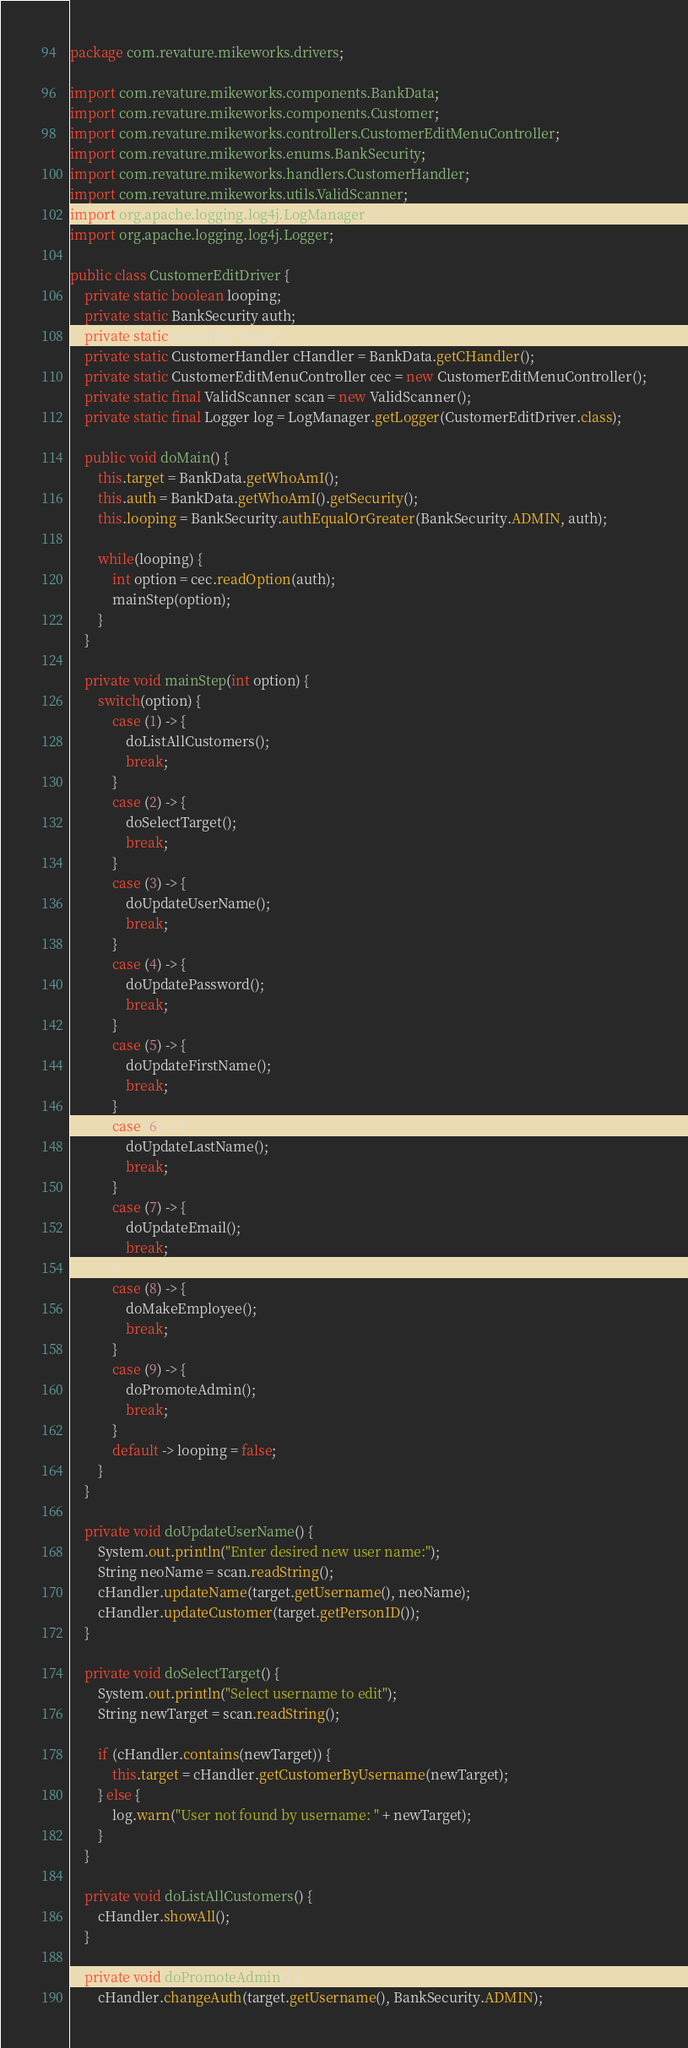<code> <loc_0><loc_0><loc_500><loc_500><_Java_>package com.revature.mikeworks.drivers;

import com.revature.mikeworks.components.BankData;
import com.revature.mikeworks.components.Customer;
import com.revature.mikeworks.controllers.CustomerEditMenuController;
import com.revature.mikeworks.enums.BankSecurity;
import com.revature.mikeworks.handlers.CustomerHandler;
import com.revature.mikeworks.utils.ValidScanner;
import org.apache.logging.log4j.LogManager;
import org.apache.logging.log4j.Logger;

public class CustomerEditDriver {
    private static boolean looping;
    private static BankSecurity auth;
    private static Customer target;
    private static CustomerHandler cHandler = BankData.getCHandler();
    private static CustomerEditMenuController cec = new CustomerEditMenuController();
    private static final ValidScanner scan = new ValidScanner();
    private static final Logger log = LogManager.getLogger(CustomerEditDriver.class);

    public void doMain() {
        this.target = BankData.getWhoAmI();
        this.auth = BankData.getWhoAmI().getSecurity();
        this.looping = BankSecurity.authEqualOrGreater(BankSecurity.ADMIN, auth);

        while(looping) {
            int option = cec.readOption(auth);
            mainStep(option);
        }
    }

    private void mainStep(int option) {
        switch(option) {
            case (1) -> {
                doListAllCustomers();
                break;
            }
            case (2) -> {
                doSelectTarget();
                break;
            }
            case (3) -> {
                doUpdateUserName();
                break;
            }
            case (4) -> {
                doUpdatePassword();
                break;
            }
            case (5) -> {
                doUpdateFirstName();
                break;
            }
            case (6) -> {
                doUpdateLastName();
                break;
            }
            case (7) -> {
                doUpdateEmail();
                break;
            }
            case (8) -> {
                doMakeEmployee();
                break;
            }
            case (9) -> {
                doPromoteAdmin();
                break;
            }
            default -> looping = false;
        }
    }

    private void doUpdateUserName() {
        System.out.println("Enter desired new user name:");
        String neoName = scan.readString();
        cHandler.updateName(target.getUsername(), neoName);
        cHandler.updateCustomer(target.getPersonID());
    }

    private void doSelectTarget() {
        System.out.println("Select username to edit");
        String newTarget = scan.readString();

        if (cHandler.contains(newTarget)) {
            this.target = cHandler.getCustomerByUsername(newTarget);
        } else {
            log.warn("User not found by username: " + newTarget);
        }
    }

    private void doListAllCustomers() {
        cHandler.showAll();
    }

    private void doPromoteAdmin() {
        cHandler.changeAuth(target.getUsername(), BankSecurity.ADMIN);</code> 